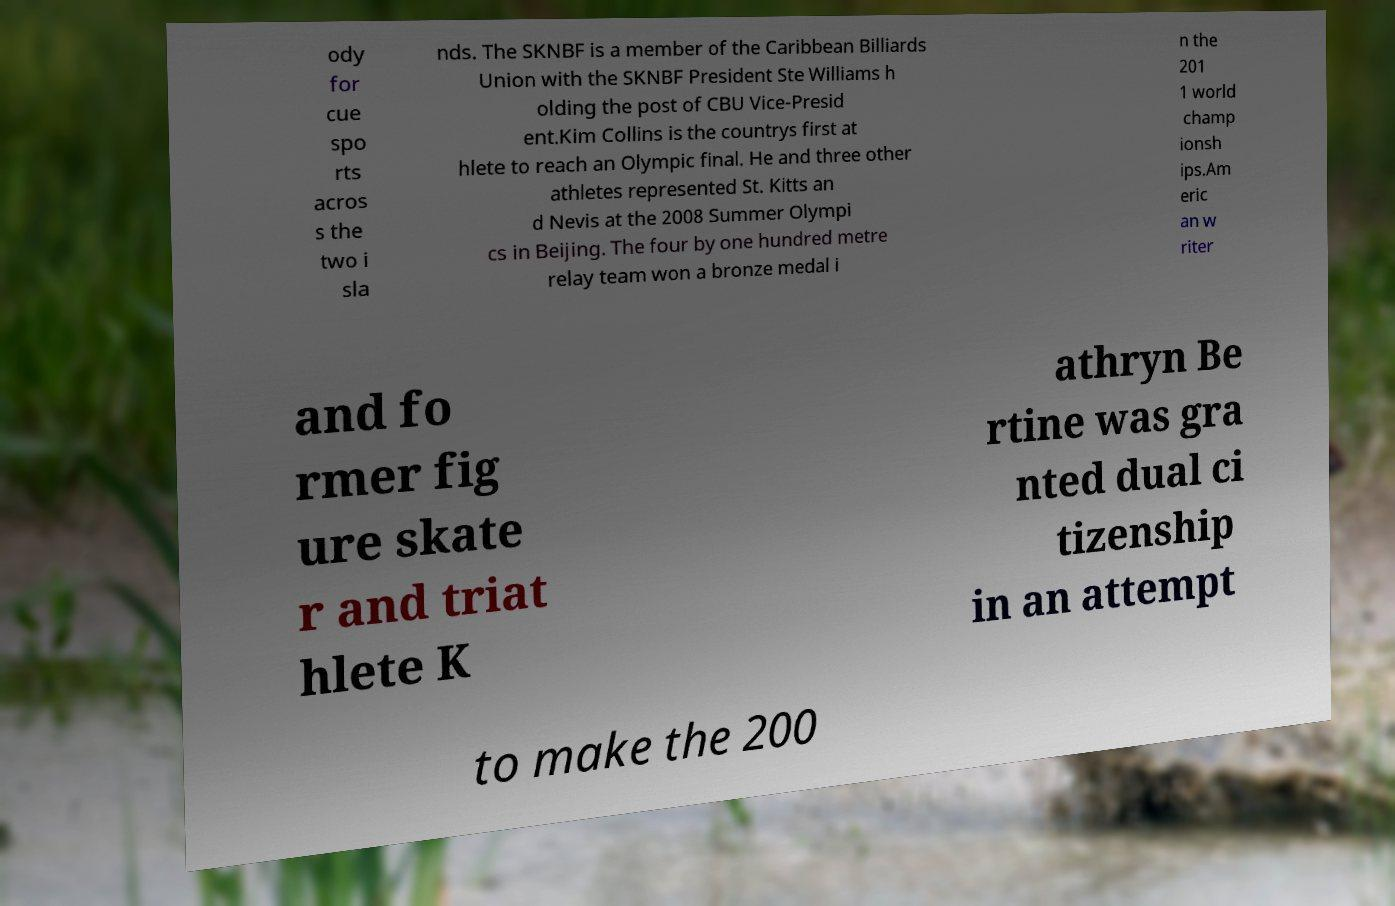Can you read and provide the text displayed in the image?This photo seems to have some interesting text. Can you extract and type it out for me? ody for cue spo rts acros s the two i sla nds. The SKNBF is a member of the Caribbean Billiards Union with the SKNBF President Ste Williams h olding the post of CBU Vice-Presid ent.Kim Collins is the countrys first at hlete to reach an Olympic final. He and three other athletes represented St. Kitts an d Nevis at the 2008 Summer Olympi cs in Beijing. The four by one hundred metre relay team won a bronze medal i n the 201 1 world champ ionsh ips.Am eric an w riter and fo rmer fig ure skate r and triat hlete K athryn Be rtine was gra nted dual ci tizenship in an attempt to make the 200 